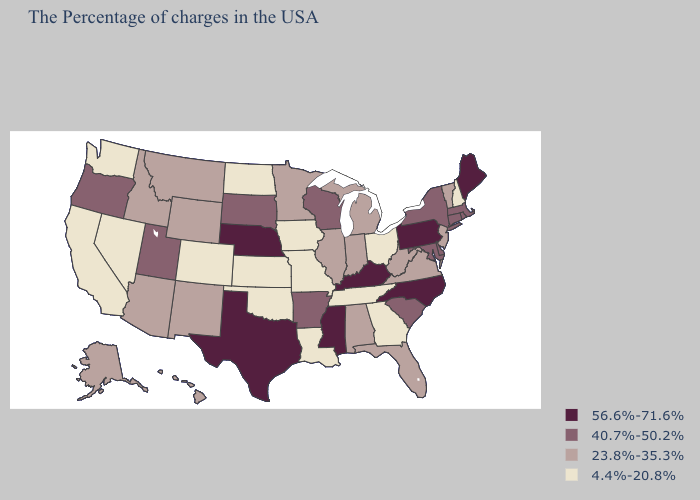Name the states that have a value in the range 40.7%-50.2%?
Write a very short answer. Massachusetts, Rhode Island, Connecticut, New York, Delaware, Maryland, South Carolina, Wisconsin, Arkansas, South Dakota, Utah, Oregon. What is the highest value in states that border Louisiana?
Answer briefly. 56.6%-71.6%. Name the states that have a value in the range 23.8%-35.3%?
Quick response, please. Vermont, New Jersey, Virginia, West Virginia, Florida, Michigan, Indiana, Alabama, Illinois, Minnesota, Wyoming, New Mexico, Montana, Arizona, Idaho, Alaska, Hawaii. Name the states that have a value in the range 40.7%-50.2%?
Keep it brief. Massachusetts, Rhode Island, Connecticut, New York, Delaware, Maryland, South Carolina, Wisconsin, Arkansas, South Dakota, Utah, Oregon. Which states have the lowest value in the West?
Short answer required. Colorado, Nevada, California, Washington. What is the highest value in the USA?
Quick response, please. 56.6%-71.6%. Does Minnesota have a lower value than Texas?
Answer briefly. Yes. What is the value of Maine?
Quick response, please. 56.6%-71.6%. What is the value of North Dakota?
Keep it brief. 4.4%-20.8%. What is the value of New Jersey?
Write a very short answer. 23.8%-35.3%. What is the highest value in the South ?
Be succinct. 56.6%-71.6%. Does Virginia have the lowest value in the USA?
Short answer required. No. Does Vermont have the same value as Georgia?
Concise answer only. No. Does Nebraska have the highest value in the MidWest?
Short answer required. Yes. What is the lowest value in states that border Georgia?
Write a very short answer. 4.4%-20.8%. 